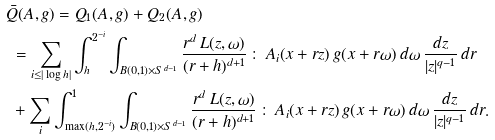<formula> <loc_0><loc_0><loc_500><loc_500>& \bar { Q } ( A , g ) = Q _ { 1 } ( A , g ) + Q _ { 2 } ( A , g ) \\ & \ = \sum _ { i \leq | \log h | } \int _ { h } ^ { 2 ^ { - i } } \int _ { B ( 0 , 1 ) \times S ^ { d - 1 } } \frac { r ^ { d } \, L ( z , \omega ) } { ( r + h ) ^ { d + 1 } } \, \colon \, A _ { i } ( x + r z ) \, g ( x + r \omega ) \, d \omega \, \frac { d z } { | z | ^ { q - 1 } } \, d r \\ & \ + \sum _ { i } \int _ { \max ( h , 2 ^ { - i } ) } ^ { 1 } \int _ { B ( 0 , 1 ) \times S ^ { d - 1 } } \frac { r ^ { d } \, L ( z , \omega ) } { ( r + h ) ^ { d + 1 } } \, \colon \, A _ { i } ( x + r z ) \, g ( x + r \omega ) \, d \omega \, \frac { d z } { | z | ^ { q - 1 } } \, d r .</formula> 